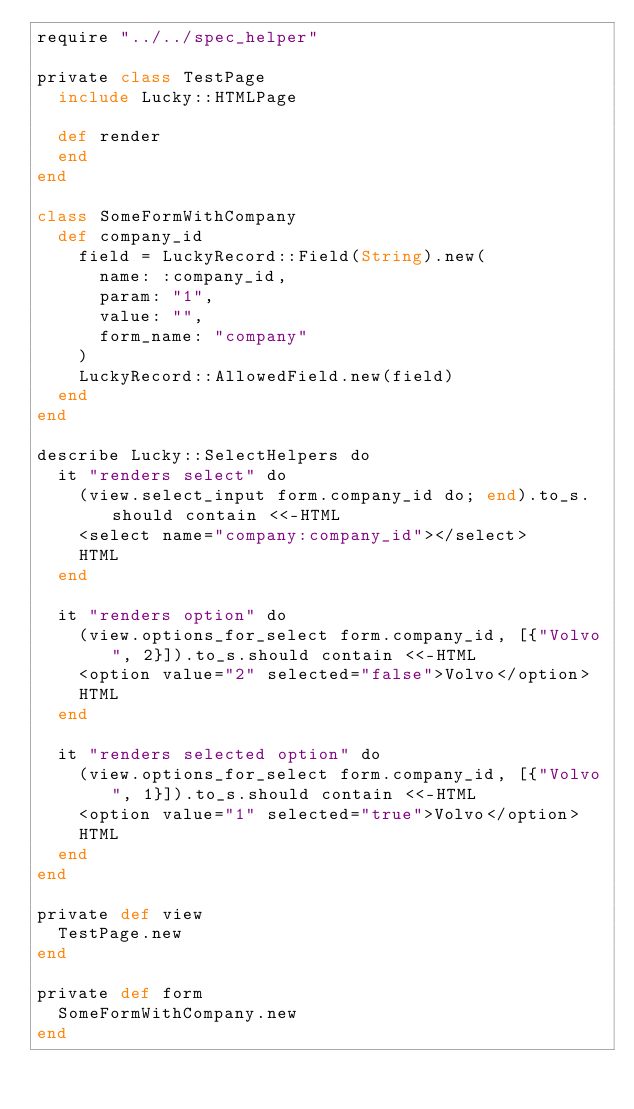Convert code to text. <code><loc_0><loc_0><loc_500><loc_500><_Crystal_>require "../../spec_helper"

private class TestPage
  include Lucky::HTMLPage

  def render
  end
end

class SomeFormWithCompany
  def company_id
    field = LuckyRecord::Field(String).new(
      name: :company_id,
      param: "1",
      value: "",
      form_name: "company"
    )
    LuckyRecord::AllowedField.new(field)
  end
end

describe Lucky::SelectHelpers do
  it "renders select" do
    (view.select_input form.company_id do; end).to_s.should contain <<-HTML
    <select name="company:company_id"></select>
    HTML
  end

  it "renders option" do
    (view.options_for_select form.company_id, [{"Volvo", 2}]).to_s.should contain <<-HTML
    <option value="2" selected="false">Volvo</option>
    HTML
  end

  it "renders selected option" do
    (view.options_for_select form.company_id, [{"Volvo", 1}]).to_s.should contain <<-HTML
    <option value="1" selected="true">Volvo</option>
    HTML
  end
end

private def view
  TestPage.new
end

private def form
  SomeFormWithCompany.new
end
</code> 